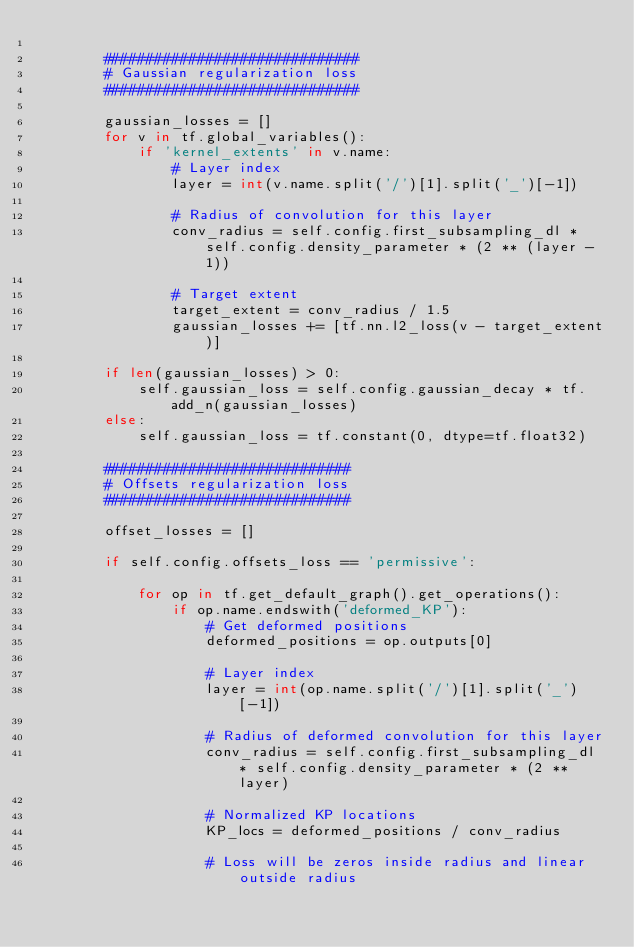Convert code to text. <code><loc_0><loc_0><loc_500><loc_500><_Python_>
        ##############################
        # Gaussian regularization loss
        ##############################

        gaussian_losses = []
        for v in tf.global_variables():
            if 'kernel_extents' in v.name:
                # Layer index
                layer = int(v.name.split('/')[1].split('_')[-1])

                # Radius of convolution for this layer
                conv_radius = self.config.first_subsampling_dl * self.config.density_parameter * (2 ** (layer - 1))

                # Target extent
                target_extent = conv_radius / 1.5
                gaussian_losses += [tf.nn.l2_loss(v - target_extent)]

        if len(gaussian_losses) > 0:
            self.gaussian_loss = self.config.gaussian_decay * tf.add_n(gaussian_losses)
        else:
            self.gaussian_loss = tf.constant(0, dtype=tf.float32)

        #############################
        # Offsets regularization loss
        #############################

        offset_losses = []

        if self.config.offsets_loss == 'permissive':

            for op in tf.get_default_graph().get_operations():
                if op.name.endswith('deformed_KP'):
                    # Get deformed positions
                    deformed_positions = op.outputs[0]

                    # Layer index
                    layer = int(op.name.split('/')[1].split('_')[-1])

                    # Radius of deformed convolution for this layer
                    conv_radius = self.config.first_subsampling_dl * self.config.density_parameter * (2 ** layer)

                    # Normalized KP locations
                    KP_locs = deformed_positions / conv_radius

                    # Loss will be zeros inside radius and linear outside radius</code> 